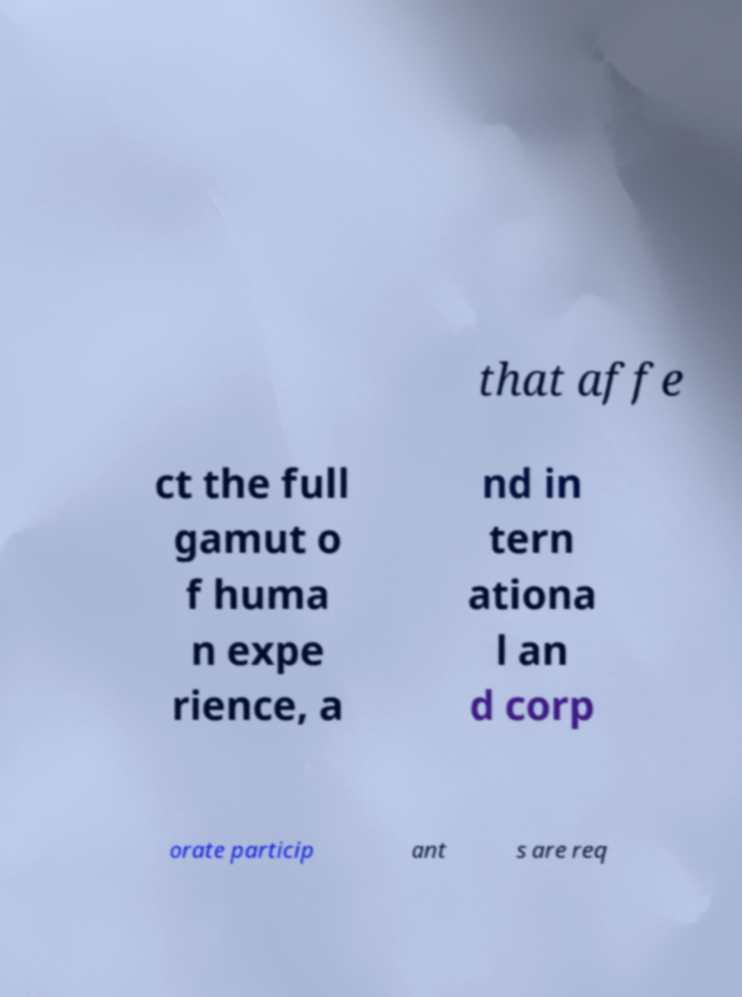Can you accurately transcribe the text from the provided image for me? that affe ct the full gamut o f huma n expe rience, a nd in tern ationa l an d corp orate particip ant s are req 